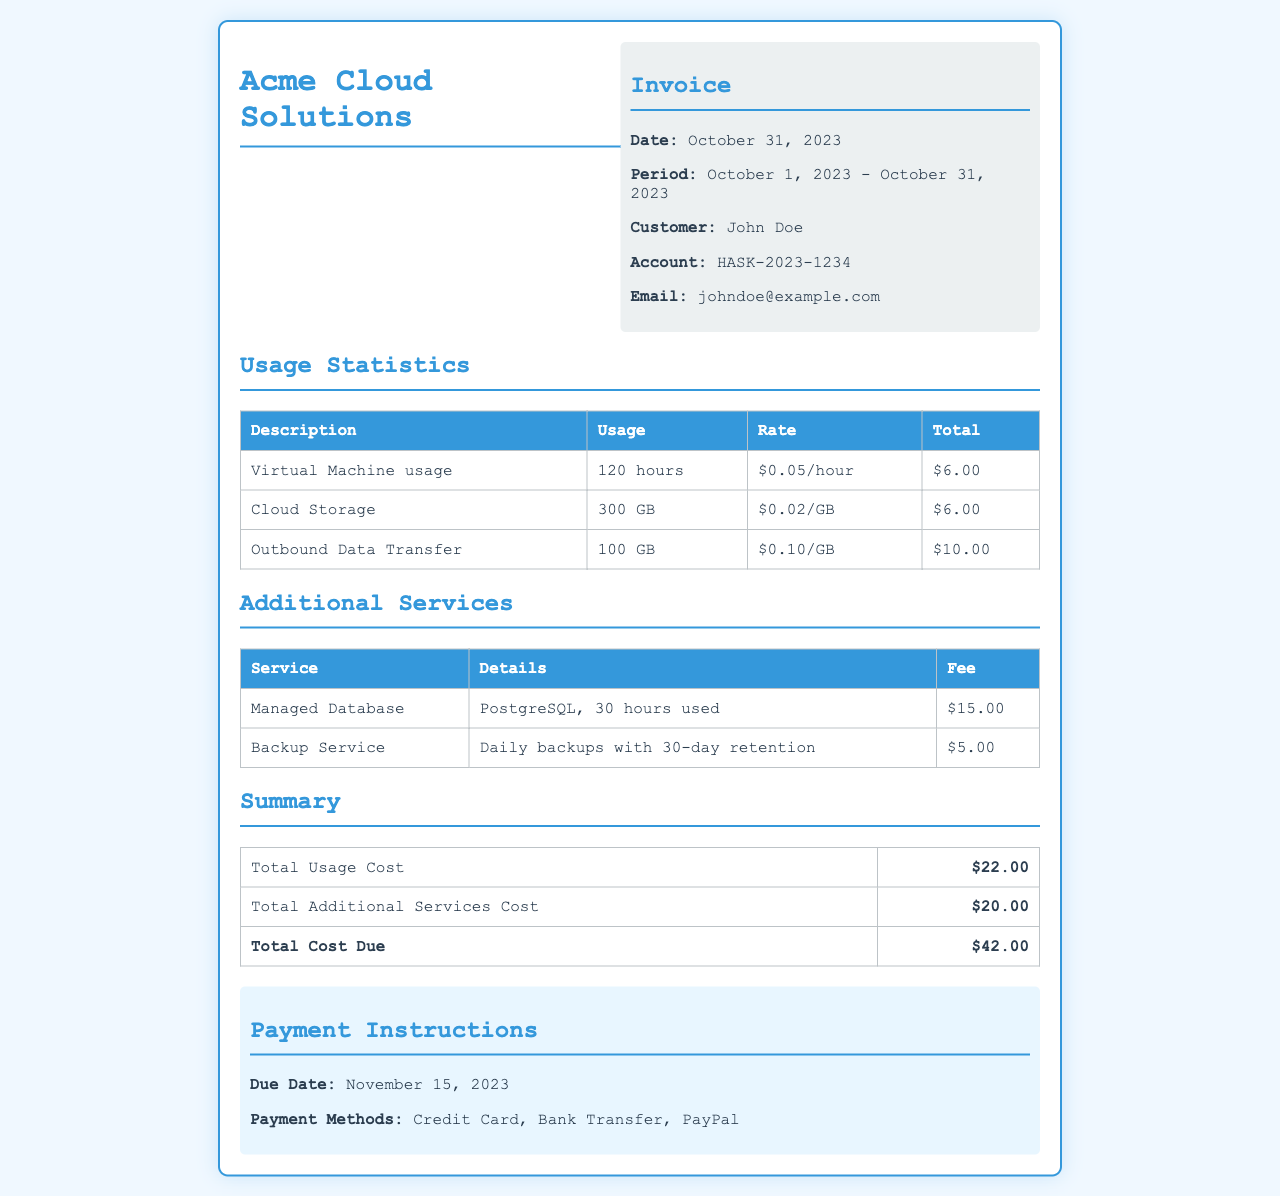what is the total cost due? The total cost due is presented in the summary table at the end of the invoice.
Answer: $42.00 who is the customer? The customer's name is listed in the customer information section of the invoice.
Answer: John Doe what is the period of the invoice? The period is specified in the header section of the invoice between the dates of usage.
Answer: October 1, 2023 - October 31, 2023 how many gigabytes of Cloud Storage were used? The usage statistics table provides the amount of Cloud Storage used.
Answer: 300 GB what is the fee for the Managed Database service? The fee for the Managed Database service is stated in the additional services table.
Answer: $15.00 what usage incurred the highest cost? The reasoning requires comparing the total costs from the usage statistics table, which shows the highest total.
Answer: Outbound Data Transfer when is the payment due? The due date for payment is mentioned in the payment instructions section of the invoice.
Answer: November 15, 2023 how many hours of Virtual Machine usage were recorded? The duration of Virtual Machine usage is listed in the usage statistics table.
Answer: 120 hours what payment methods are accepted? This information is found in the payment instructions section of the invoice.
Answer: Credit Card, Bank Transfer, PayPal 